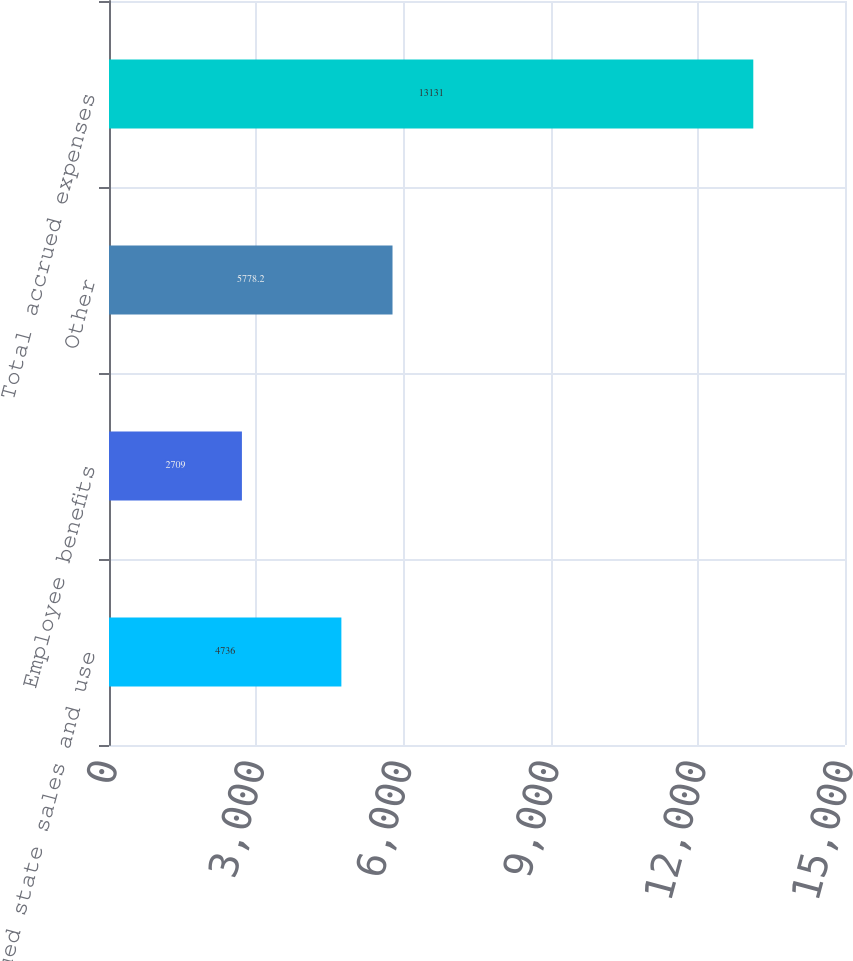Convert chart. <chart><loc_0><loc_0><loc_500><loc_500><bar_chart><fcel>Accrued state sales and use<fcel>Employee benefits<fcel>Other<fcel>Total accrued expenses<nl><fcel>4736<fcel>2709<fcel>5778.2<fcel>13131<nl></chart> 